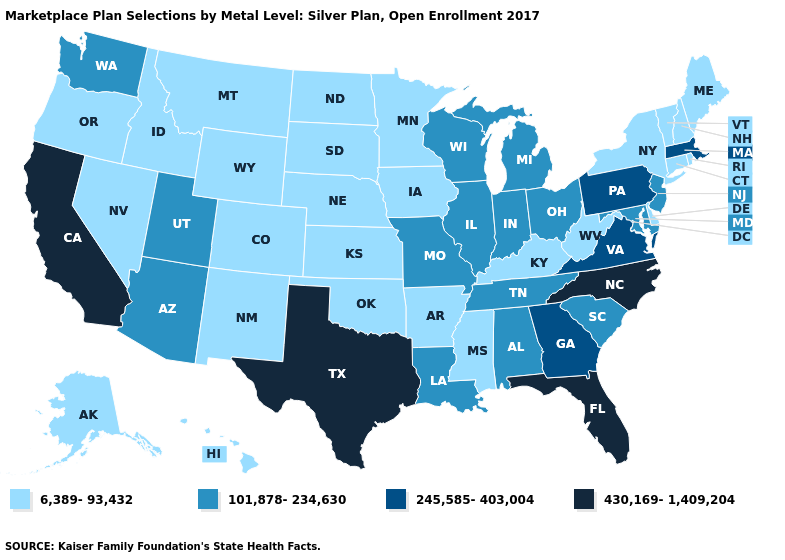Name the states that have a value in the range 6,389-93,432?
Keep it brief. Alaska, Arkansas, Colorado, Connecticut, Delaware, Hawaii, Idaho, Iowa, Kansas, Kentucky, Maine, Minnesota, Mississippi, Montana, Nebraska, Nevada, New Hampshire, New Mexico, New York, North Dakota, Oklahoma, Oregon, Rhode Island, South Dakota, Vermont, West Virginia, Wyoming. Does New Mexico have the lowest value in the USA?
Concise answer only. Yes. How many symbols are there in the legend?
Keep it brief. 4. Name the states that have a value in the range 430,169-1,409,204?
Write a very short answer. California, Florida, North Carolina, Texas. Which states hav the highest value in the South?
Concise answer only. Florida, North Carolina, Texas. Name the states that have a value in the range 430,169-1,409,204?
Answer briefly. California, Florida, North Carolina, Texas. What is the lowest value in states that border Minnesota?
Be succinct. 6,389-93,432. Among the states that border Texas , does Arkansas have the lowest value?
Answer briefly. Yes. Among the states that border Missouri , which have the lowest value?
Quick response, please. Arkansas, Iowa, Kansas, Kentucky, Nebraska, Oklahoma. Which states have the highest value in the USA?
Write a very short answer. California, Florida, North Carolina, Texas. Name the states that have a value in the range 245,585-403,004?
Quick response, please. Georgia, Massachusetts, Pennsylvania, Virginia. What is the value of Missouri?
Quick response, please. 101,878-234,630. Which states have the highest value in the USA?
Quick response, please. California, Florida, North Carolina, Texas. Name the states that have a value in the range 430,169-1,409,204?
Short answer required. California, Florida, North Carolina, Texas. Does the first symbol in the legend represent the smallest category?
Short answer required. Yes. 